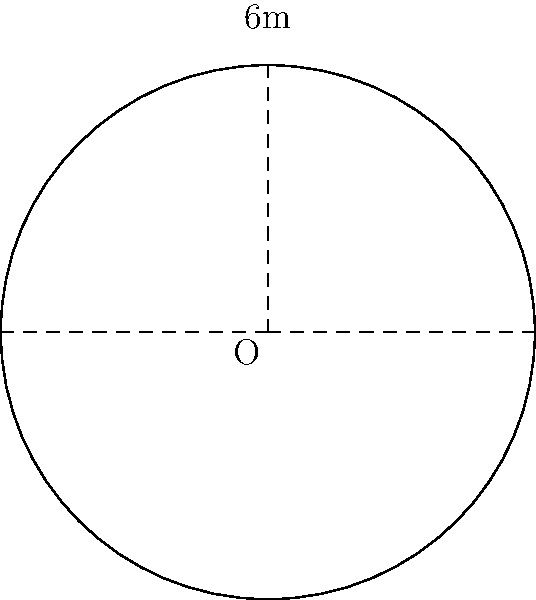For your latest art installation, you've created a circular sculpture using recycled bicycle wheels. The diameter of the sculpture is 6 meters. What is the circumference of this circular installation? To find the circumference of the circular art installation, we'll follow these steps:

1. Recall the formula for circumference of a circle:
   $C = 2\pi r$ or $C = \pi d$
   Where $C$ is circumference, $r$ is radius, and $d$ is diameter.

2. We're given the diameter $d = 6$ meters.

3. Let's use the formula $C = \pi d$:
   $C = \pi \cdot 6$

4. $\pi$ is approximately 3.14159, so:
   $C \approx 3.14159 \cdot 6$

5. Calculating:
   $C \approx 18.84954$ meters

6. Rounding to two decimal places:
   $C \approx 18.85$ meters

Therefore, the circumference of the circular art installation is approximately 18.85 meters.
Answer: 18.85 meters 